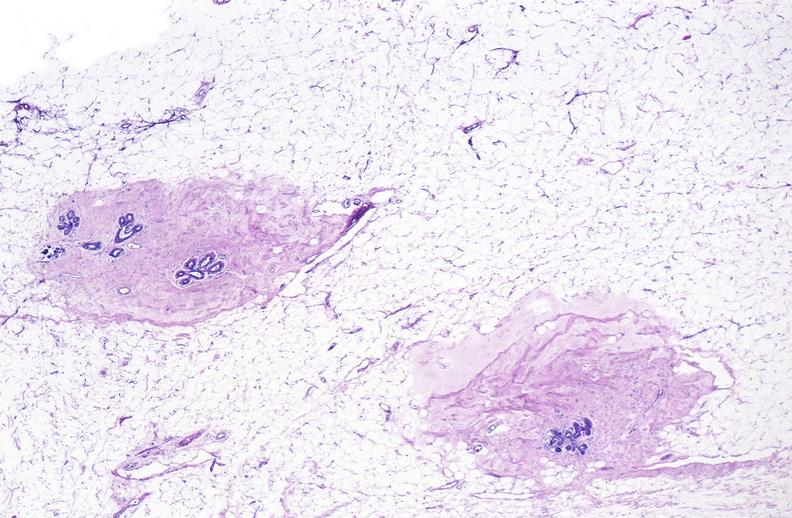does lateral view show normal breast?
Answer the question using a single word or phrase. No 